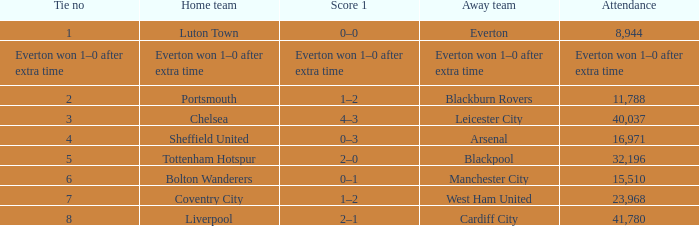What home team had an audience record of 16,971? Sheffield United. Parse the full table. {'header': ['Tie no', 'Home team', 'Score 1', 'Away team', 'Attendance'], 'rows': [['1', 'Luton Town', '0–0', 'Everton', '8,944'], ['Everton won 1–0 after extra time', 'Everton won 1–0 after extra time', 'Everton won 1–0 after extra time', 'Everton won 1–0 after extra time', 'Everton won 1–0 after extra time'], ['2', 'Portsmouth', '1–2', 'Blackburn Rovers', '11,788'], ['3', 'Chelsea', '4–3', 'Leicester City', '40,037'], ['4', 'Sheffield United', '0–3', 'Arsenal', '16,971'], ['5', 'Tottenham Hotspur', '2–0', 'Blackpool', '32,196'], ['6', 'Bolton Wanderers', '0–1', 'Manchester City', '15,510'], ['7', 'Coventry City', '1–2', 'West Ham United', '23,968'], ['8', 'Liverpool', '2–1', 'Cardiff City', '41,780']]} 